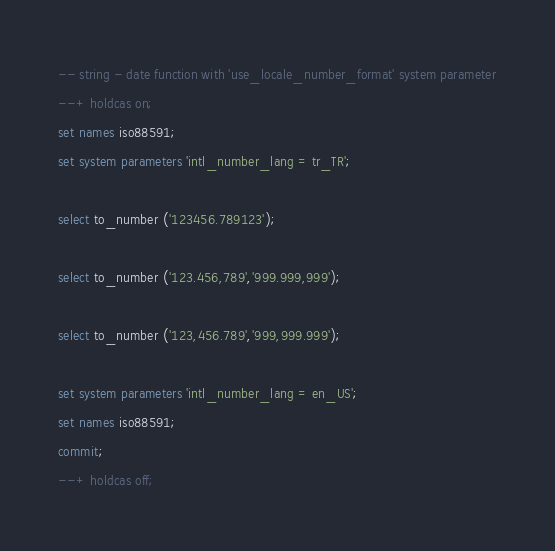<code> <loc_0><loc_0><loc_500><loc_500><_SQL_>-- string - date function with 'use_locale_number_format' system parameter
--+ holdcas on;
set names iso88591;
set system parameters 'intl_number_lang = tr_TR';

select to_number ('123456.789123');

select to_number ('123.456,789','999.999,999');

select to_number ('123,456.789','999,999.999');

set system parameters 'intl_number_lang = en_US';
set names iso88591;
commit;
--+ holdcas off;
</code> 